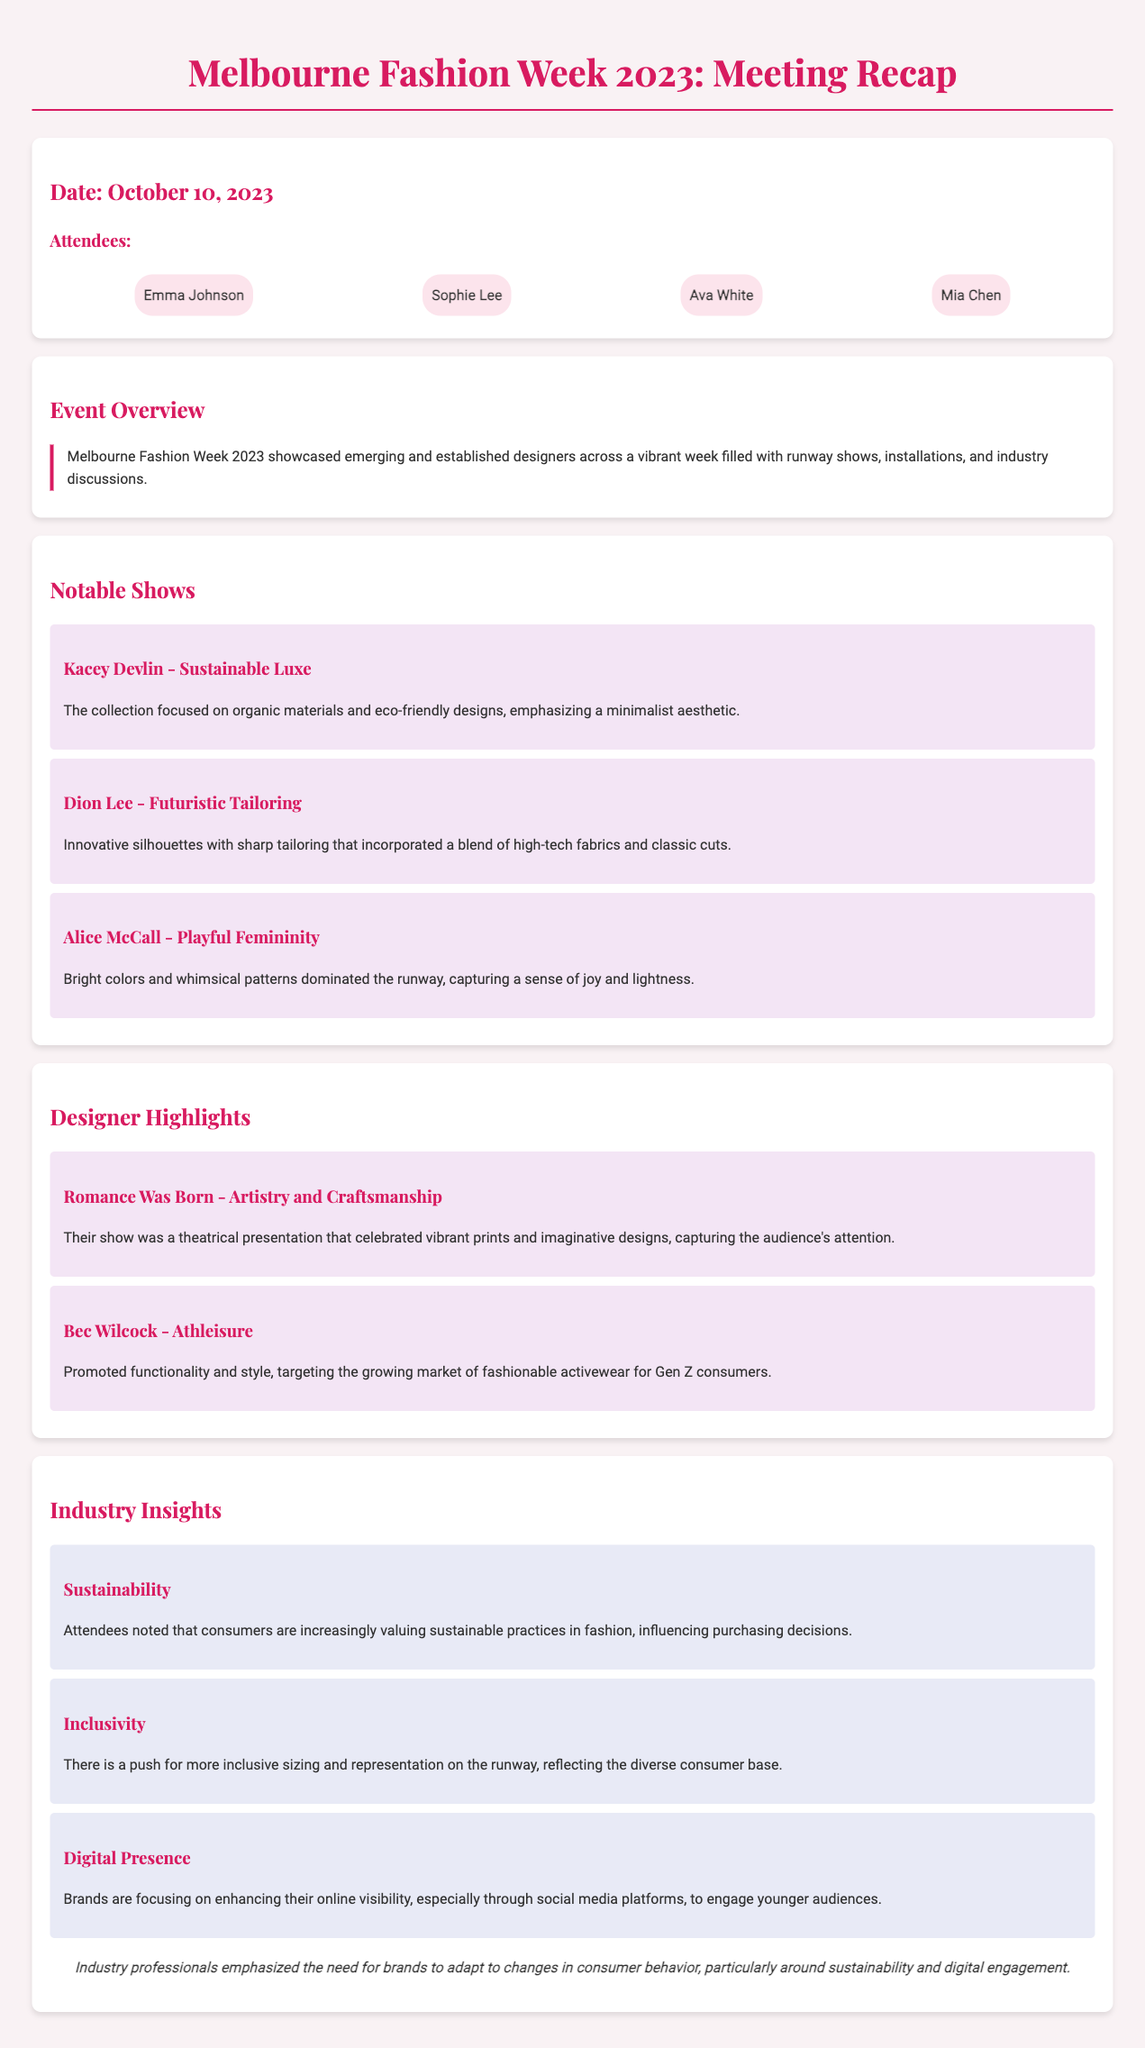What date was the meeting held? The meeting was held on the date mentioned at the beginning of the document.
Answer: October 10, 2023 Who was one of the attendees? The attendee names are listed in the attendees section of the document.
Answer: Emma Johnson What was the focus of Kacey Devlin's collection? The notable shows section details the focus of Kacey Devlin's collection.
Answer: Sustainable Luxe Which designer emphasized athleisure? The designer highlights section specifies which designer focused on athleisure.
Answer: Bec Wilcock What is a key consumer trend noted in the insights? The industry insights section lists trends that consumers are currently valuing in fashion.
Answer: Sustainability How are brands engaging younger audiences according to the document? The industry insights section explains how brands are enhancing their online visibility.
Answer: Social media platforms What was emphasized by industry professionals at the end of the document? The conclusion provides a summary of points emphasized by industry professionals.
Answer: Adapt to changes in consumer behavior 